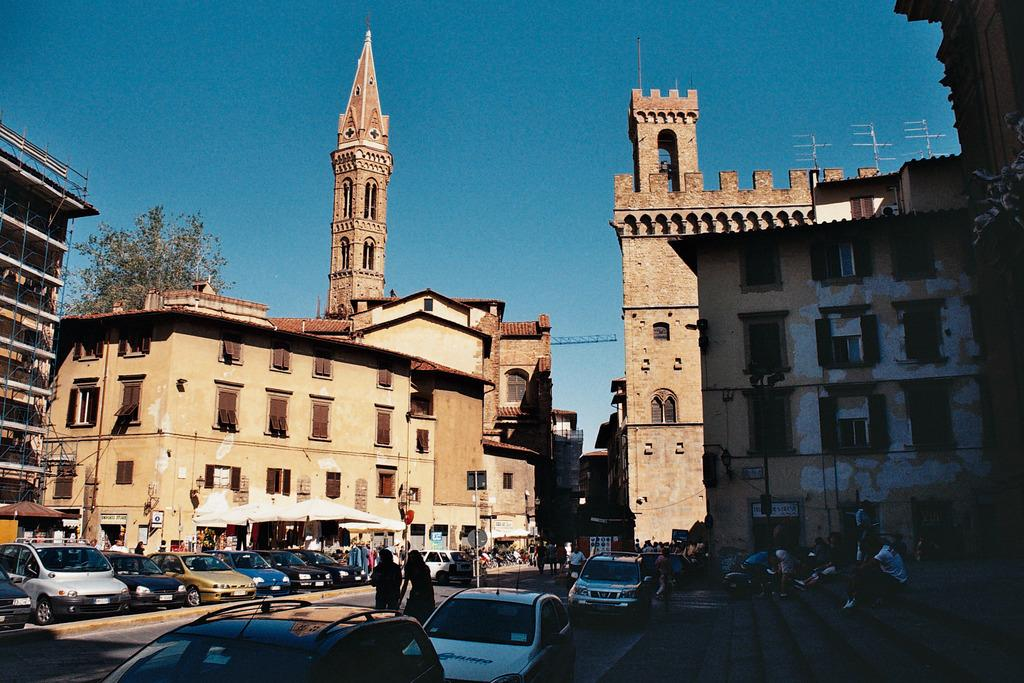What is happening on the road in the image? There are vehicles on the road in the image. Can you describe the people in the image? People are present in the image. What objects can be seen in the foreground of the image? Poles are visible in the image. What can be seen in the background of the image? There are buildings, trees, and the sky visible in the background. What is the color of the sky in the image? The sky is blue in color. What feature do the buildings have? The buildings have windows. Where is the garden located in the image? There is no garden present in the image. What type of tax is being discussed by the people in the image? There is no discussion of tax in the image. How many pigs can be seen in the image? There are no pigs present in the image. 